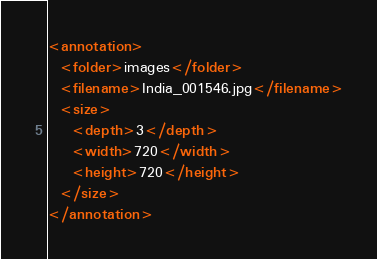<code> <loc_0><loc_0><loc_500><loc_500><_XML_><annotation>
  <folder>images</folder>
  <filename>India_001546.jpg</filename>
  <size>
    <depth>3</depth>
    <width>720</width>
    <height>720</height>
  </size>
</annotation></code> 